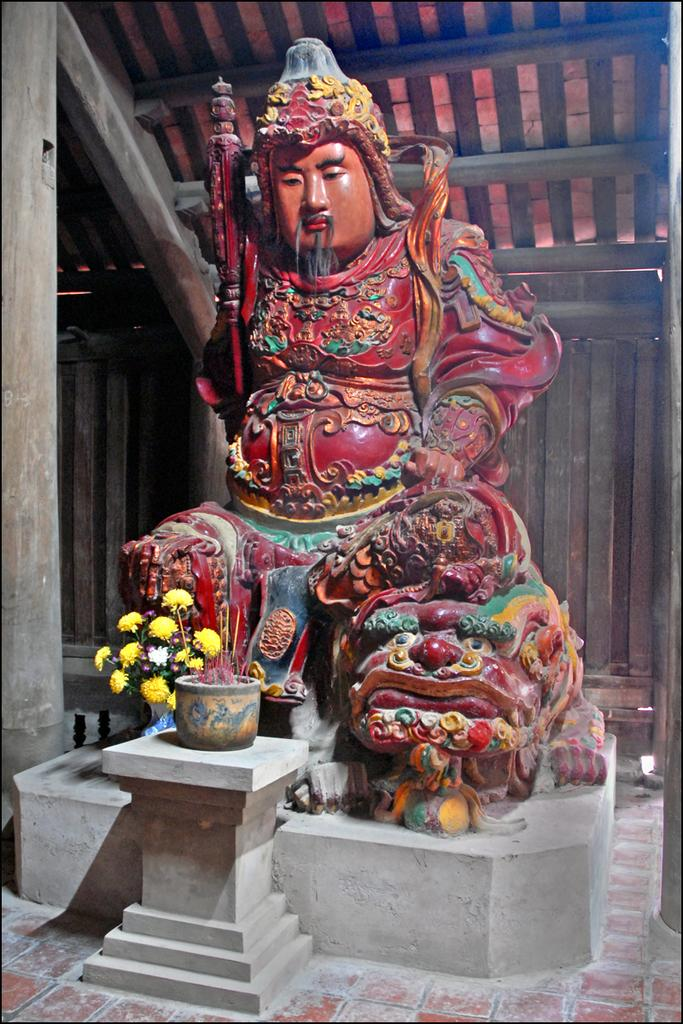What is the main subject in the image? There is a statue in the image. Can you describe the appearance of the statue? The statue has different colors. What type of flowers can be seen in the image? There are yellow color flowers in the image. What is the statue placed in or on? There is a pot in the image. What type of structure is visible in the background? There is a wooden shed in the image. Can you see any square-shaped icicles hanging from the statue in the image? There are no icicles present in the image, and the statue is not square-shaped. 